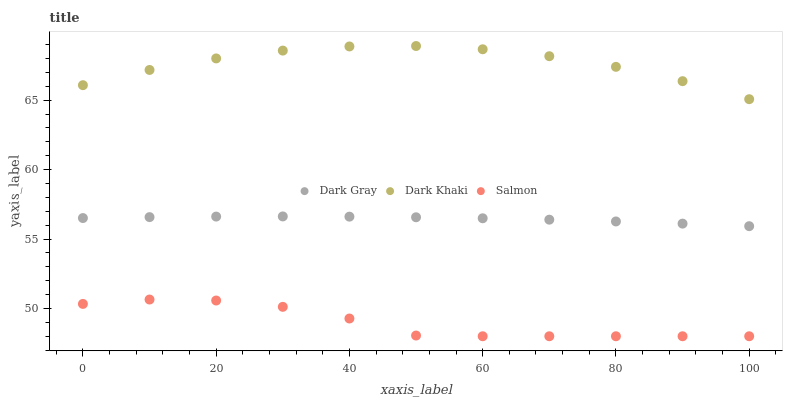Does Salmon have the minimum area under the curve?
Answer yes or no. Yes. Does Dark Khaki have the maximum area under the curve?
Answer yes or no. Yes. Does Dark Khaki have the minimum area under the curve?
Answer yes or no. No. Does Salmon have the maximum area under the curve?
Answer yes or no. No. Is Dark Gray the smoothest?
Answer yes or no. Yes. Is Salmon the roughest?
Answer yes or no. Yes. Is Dark Khaki the smoothest?
Answer yes or no. No. Is Dark Khaki the roughest?
Answer yes or no. No. Does Salmon have the lowest value?
Answer yes or no. Yes. Does Dark Khaki have the lowest value?
Answer yes or no. No. Does Dark Khaki have the highest value?
Answer yes or no. Yes. Does Salmon have the highest value?
Answer yes or no. No. Is Salmon less than Dark Khaki?
Answer yes or no. Yes. Is Dark Gray greater than Salmon?
Answer yes or no. Yes. Does Salmon intersect Dark Khaki?
Answer yes or no. No. 